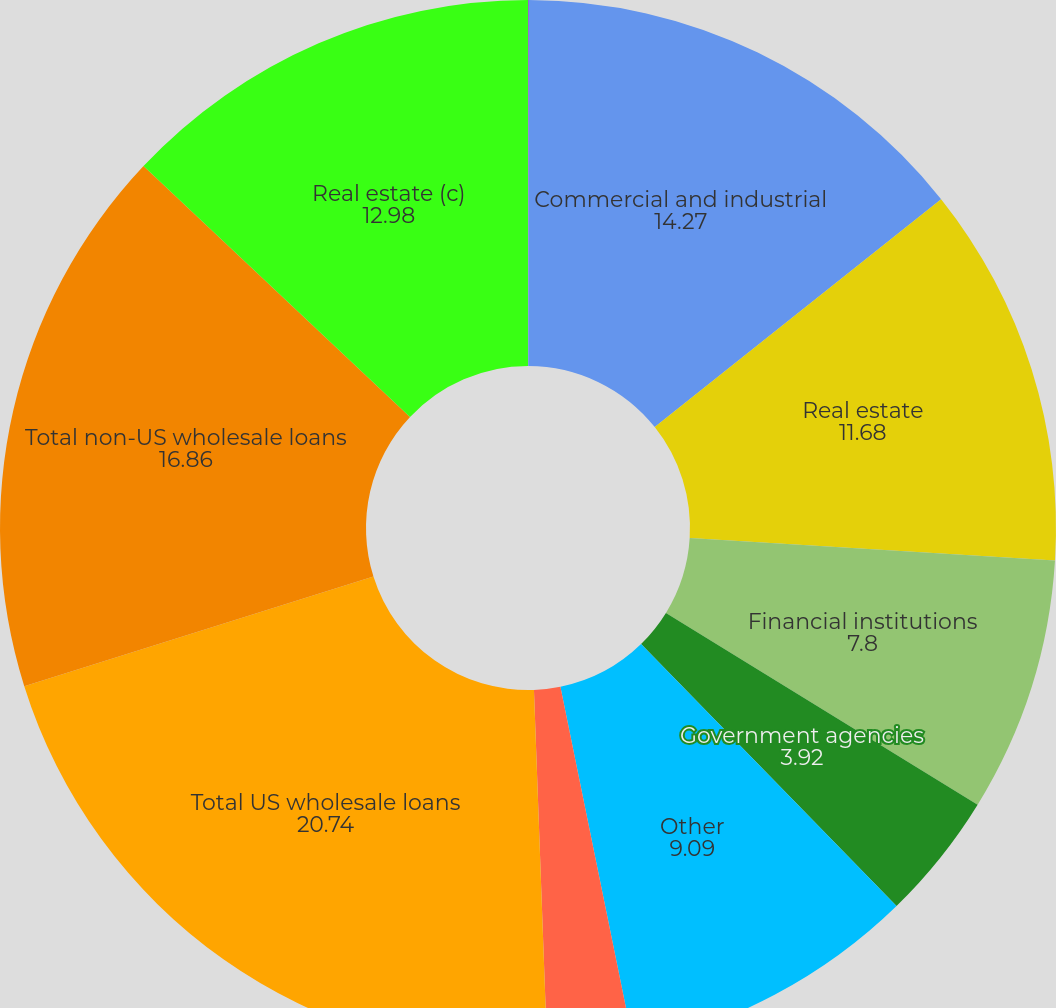<chart> <loc_0><loc_0><loc_500><loc_500><pie_chart><fcel>December 31 (in millions)<fcel>Commercial and industrial<fcel>Real estate<fcel>Financial institutions<fcel>Government agencies<fcel>Other<fcel>Loans held-for-sale and at<fcel>Total US wholesale loans<fcel>Total non-US wholesale loans<fcel>Real estate (c)<nl><fcel>0.03%<fcel>14.27%<fcel>11.68%<fcel>7.8%<fcel>3.92%<fcel>9.09%<fcel>2.62%<fcel>20.74%<fcel>16.86%<fcel>12.98%<nl></chart> 